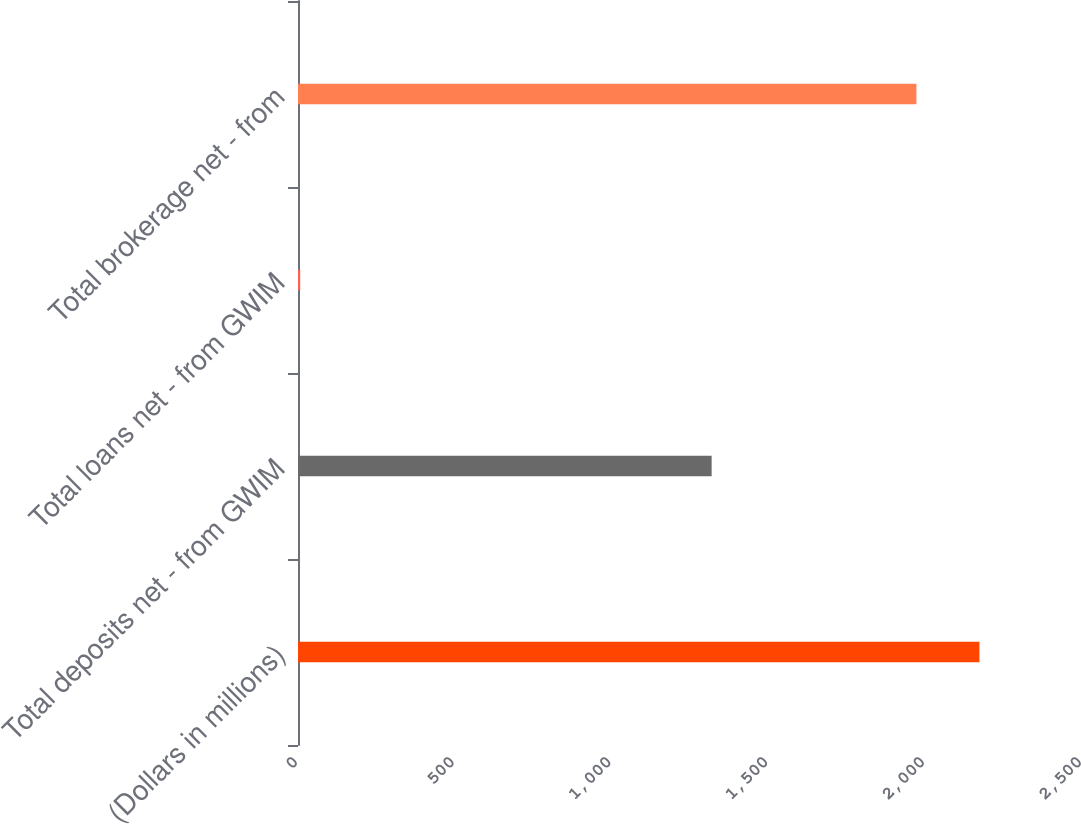Convert chart. <chart><loc_0><loc_0><loc_500><loc_500><bar_chart><fcel>(Dollars in millions)<fcel>Total deposits net - from GWIM<fcel>Total loans net - from GWIM<fcel>Total brokerage net - from<nl><fcel>2172.9<fcel>1319<fcel>7<fcel>1972<nl></chart> 